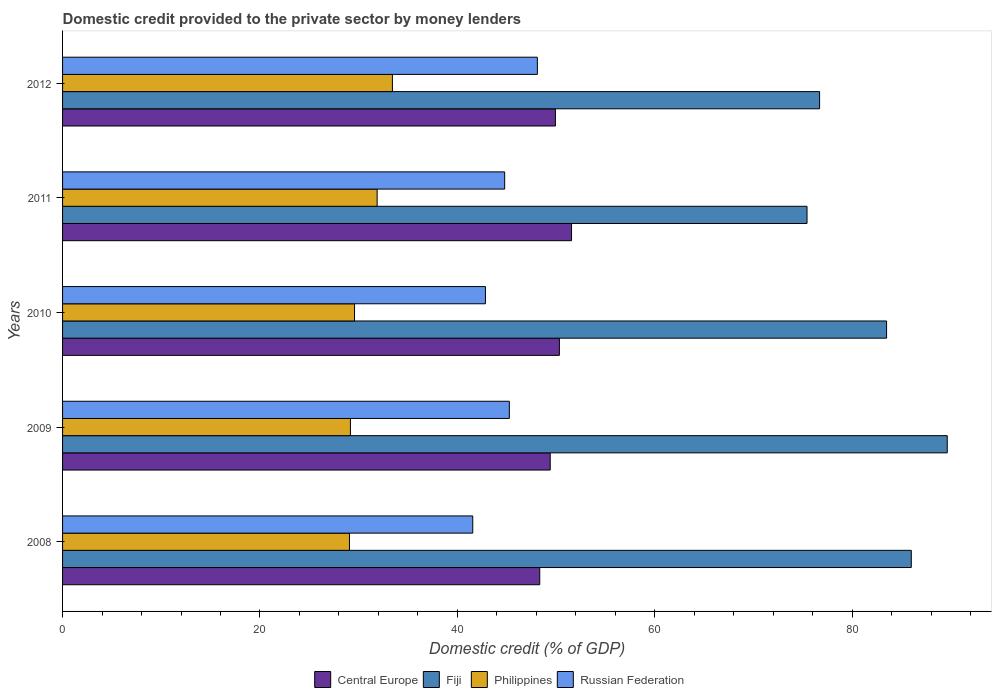How many different coloured bars are there?
Give a very brief answer. 4. How many groups of bars are there?
Your response must be concise. 5. Are the number of bars per tick equal to the number of legend labels?
Offer a terse response. Yes. How many bars are there on the 2nd tick from the top?
Keep it short and to the point. 4. How many bars are there on the 2nd tick from the bottom?
Provide a short and direct response. 4. In how many cases, is the number of bars for a given year not equal to the number of legend labels?
Provide a succinct answer. 0. What is the domestic credit provided to the private sector by money lenders in Philippines in 2012?
Offer a very short reply. 33.41. Across all years, what is the maximum domestic credit provided to the private sector by money lenders in Central Europe?
Ensure brevity in your answer.  51.56. Across all years, what is the minimum domestic credit provided to the private sector by money lenders in Central Europe?
Your answer should be very brief. 48.34. In which year was the domestic credit provided to the private sector by money lenders in Central Europe maximum?
Your answer should be compact. 2011. What is the total domestic credit provided to the private sector by money lenders in Central Europe in the graph?
Ensure brevity in your answer.  249.56. What is the difference between the domestic credit provided to the private sector by money lenders in Philippines in 2009 and that in 2012?
Offer a very short reply. -4.25. What is the difference between the domestic credit provided to the private sector by money lenders in Philippines in 2011 and the domestic credit provided to the private sector by money lenders in Central Europe in 2008?
Keep it short and to the point. -16.47. What is the average domestic credit provided to the private sector by money lenders in Central Europe per year?
Keep it short and to the point. 49.91. In the year 2008, what is the difference between the domestic credit provided to the private sector by money lenders in Philippines and domestic credit provided to the private sector by money lenders in Russian Federation?
Offer a very short reply. -12.49. What is the ratio of the domestic credit provided to the private sector by money lenders in Central Europe in 2009 to that in 2010?
Ensure brevity in your answer.  0.98. Is the domestic credit provided to the private sector by money lenders in Philippines in 2011 less than that in 2012?
Give a very brief answer. Yes. Is the difference between the domestic credit provided to the private sector by money lenders in Philippines in 2011 and 2012 greater than the difference between the domestic credit provided to the private sector by money lenders in Russian Federation in 2011 and 2012?
Provide a short and direct response. Yes. What is the difference between the highest and the second highest domestic credit provided to the private sector by money lenders in Russian Federation?
Make the answer very short. 2.84. What is the difference between the highest and the lowest domestic credit provided to the private sector by money lenders in Russian Federation?
Your answer should be very brief. 6.55. In how many years, is the domestic credit provided to the private sector by money lenders in Russian Federation greater than the average domestic credit provided to the private sector by money lenders in Russian Federation taken over all years?
Ensure brevity in your answer.  3. What does the 3rd bar from the top in 2012 represents?
Offer a very short reply. Fiji. What does the 2nd bar from the bottom in 2009 represents?
Your answer should be very brief. Fiji. Is it the case that in every year, the sum of the domestic credit provided to the private sector by money lenders in Philippines and domestic credit provided to the private sector by money lenders in Central Europe is greater than the domestic credit provided to the private sector by money lenders in Russian Federation?
Your answer should be compact. Yes. Are all the bars in the graph horizontal?
Make the answer very short. Yes. How many years are there in the graph?
Your answer should be compact. 5. Does the graph contain any zero values?
Make the answer very short. No. Does the graph contain grids?
Give a very brief answer. No. Where does the legend appear in the graph?
Offer a very short reply. Bottom center. How many legend labels are there?
Give a very brief answer. 4. What is the title of the graph?
Your answer should be very brief. Domestic credit provided to the private sector by money lenders. What is the label or title of the X-axis?
Make the answer very short. Domestic credit (% of GDP). What is the label or title of the Y-axis?
Your response must be concise. Years. What is the Domestic credit (% of GDP) in Central Europe in 2008?
Your answer should be very brief. 48.34. What is the Domestic credit (% of GDP) in Fiji in 2008?
Offer a very short reply. 85.98. What is the Domestic credit (% of GDP) of Philippines in 2008?
Make the answer very short. 29.06. What is the Domestic credit (% of GDP) in Russian Federation in 2008?
Offer a very short reply. 41.55. What is the Domestic credit (% of GDP) of Central Europe in 2009?
Provide a succinct answer. 49.4. What is the Domestic credit (% of GDP) in Fiji in 2009?
Make the answer very short. 89.62. What is the Domestic credit (% of GDP) of Philippines in 2009?
Provide a short and direct response. 29.16. What is the Domestic credit (% of GDP) of Russian Federation in 2009?
Your answer should be compact. 45.26. What is the Domestic credit (% of GDP) in Central Europe in 2010?
Give a very brief answer. 50.33. What is the Domestic credit (% of GDP) of Fiji in 2010?
Keep it short and to the point. 83.48. What is the Domestic credit (% of GDP) in Philippines in 2010?
Your response must be concise. 29.58. What is the Domestic credit (% of GDP) of Russian Federation in 2010?
Your answer should be very brief. 42.84. What is the Domestic credit (% of GDP) of Central Europe in 2011?
Provide a succinct answer. 51.56. What is the Domestic credit (% of GDP) in Fiji in 2011?
Provide a succinct answer. 75.42. What is the Domestic credit (% of GDP) in Philippines in 2011?
Provide a succinct answer. 31.87. What is the Domestic credit (% of GDP) of Russian Federation in 2011?
Provide a succinct answer. 44.79. What is the Domestic credit (% of GDP) of Central Europe in 2012?
Keep it short and to the point. 49.93. What is the Domestic credit (% of GDP) of Fiji in 2012?
Offer a terse response. 76.69. What is the Domestic credit (% of GDP) of Philippines in 2012?
Your answer should be very brief. 33.41. What is the Domestic credit (% of GDP) of Russian Federation in 2012?
Your answer should be very brief. 48.1. Across all years, what is the maximum Domestic credit (% of GDP) of Central Europe?
Your answer should be compact. 51.56. Across all years, what is the maximum Domestic credit (% of GDP) of Fiji?
Make the answer very short. 89.62. Across all years, what is the maximum Domestic credit (% of GDP) of Philippines?
Your answer should be compact. 33.41. Across all years, what is the maximum Domestic credit (% of GDP) in Russian Federation?
Provide a short and direct response. 48.1. Across all years, what is the minimum Domestic credit (% of GDP) of Central Europe?
Your response must be concise. 48.34. Across all years, what is the minimum Domestic credit (% of GDP) in Fiji?
Your answer should be compact. 75.42. Across all years, what is the minimum Domestic credit (% of GDP) of Philippines?
Provide a succinct answer. 29.06. Across all years, what is the minimum Domestic credit (% of GDP) of Russian Federation?
Ensure brevity in your answer.  41.55. What is the total Domestic credit (% of GDP) in Central Europe in the graph?
Provide a succinct answer. 249.56. What is the total Domestic credit (% of GDP) in Fiji in the graph?
Offer a terse response. 411.19. What is the total Domestic credit (% of GDP) in Philippines in the graph?
Your answer should be very brief. 153.09. What is the total Domestic credit (% of GDP) in Russian Federation in the graph?
Your response must be concise. 222.54. What is the difference between the Domestic credit (% of GDP) of Central Europe in 2008 and that in 2009?
Offer a terse response. -1.06. What is the difference between the Domestic credit (% of GDP) of Fiji in 2008 and that in 2009?
Offer a very short reply. -3.65. What is the difference between the Domestic credit (% of GDP) in Philippines in 2008 and that in 2009?
Provide a short and direct response. -0.1. What is the difference between the Domestic credit (% of GDP) in Russian Federation in 2008 and that in 2009?
Your answer should be compact. -3.71. What is the difference between the Domestic credit (% of GDP) in Central Europe in 2008 and that in 2010?
Your answer should be very brief. -1.99. What is the difference between the Domestic credit (% of GDP) in Fiji in 2008 and that in 2010?
Provide a short and direct response. 2.5. What is the difference between the Domestic credit (% of GDP) of Philippines in 2008 and that in 2010?
Offer a very short reply. -0.51. What is the difference between the Domestic credit (% of GDP) of Russian Federation in 2008 and that in 2010?
Offer a terse response. -1.29. What is the difference between the Domestic credit (% of GDP) of Central Europe in 2008 and that in 2011?
Your response must be concise. -3.22. What is the difference between the Domestic credit (% of GDP) of Fiji in 2008 and that in 2011?
Provide a succinct answer. 10.56. What is the difference between the Domestic credit (% of GDP) of Philippines in 2008 and that in 2011?
Give a very brief answer. -2.8. What is the difference between the Domestic credit (% of GDP) of Russian Federation in 2008 and that in 2011?
Ensure brevity in your answer.  -3.23. What is the difference between the Domestic credit (% of GDP) of Central Europe in 2008 and that in 2012?
Provide a short and direct response. -1.59. What is the difference between the Domestic credit (% of GDP) in Fiji in 2008 and that in 2012?
Provide a succinct answer. 9.29. What is the difference between the Domestic credit (% of GDP) of Philippines in 2008 and that in 2012?
Your response must be concise. -4.35. What is the difference between the Domestic credit (% of GDP) in Russian Federation in 2008 and that in 2012?
Give a very brief answer. -6.55. What is the difference between the Domestic credit (% of GDP) in Central Europe in 2009 and that in 2010?
Provide a succinct answer. -0.93. What is the difference between the Domestic credit (% of GDP) of Fiji in 2009 and that in 2010?
Your answer should be compact. 6.15. What is the difference between the Domestic credit (% of GDP) of Philippines in 2009 and that in 2010?
Ensure brevity in your answer.  -0.42. What is the difference between the Domestic credit (% of GDP) in Russian Federation in 2009 and that in 2010?
Ensure brevity in your answer.  2.42. What is the difference between the Domestic credit (% of GDP) in Central Europe in 2009 and that in 2011?
Provide a succinct answer. -2.16. What is the difference between the Domestic credit (% of GDP) in Fiji in 2009 and that in 2011?
Your answer should be very brief. 14.21. What is the difference between the Domestic credit (% of GDP) in Philippines in 2009 and that in 2011?
Provide a succinct answer. -2.71. What is the difference between the Domestic credit (% of GDP) in Russian Federation in 2009 and that in 2011?
Your answer should be compact. 0.47. What is the difference between the Domestic credit (% of GDP) of Central Europe in 2009 and that in 2012?
Your answer should be very brief. -0.53. What is the difference between the Domestic credit (% of GDP) in Fiji in 2009 and that in 2012?
Offer a very short reply. 12.93. What is the difference between the Domestic credit (% of GDP) in Philippines in 2009 and that in 2012?
Your answer should be very brief. -4.25. What is the difference between the Domestic credit (% of GDP) of Russian Federation in 2009 and that in 2012?
Offer a terse response. -2.84. What is the difference between the Domestic credit (% of GDP) of Central Europe in 2010 and that in 2011?
Your answer should be compact. -1.23. What is the difference between the Domestic credit (% of GDP) of Fiji in 2010 and that in 2011?
Your answer should be compact. 8.06. What is the difference between the Domestic credit (% of GDP) of Philippines in 2010 and that in 2011?
Provide a succinct answer. -2.29. What is the difference between the Domestic credit (% of GDP) in Russian Federation in 2010 and that in 2011?
Give a very brief answer. -1.95. What is the difference between the Domestic credit (% of GDP) of Central Europe in 2010 and that in 2012?
Your response must be concise. 0.4. What is the difference between the Domestic credit (% of GDP) of Fiji in 2010 and that in 2012?
Your response must be concise. 6.78. What is the difference between the Domestic credit (% of GDP) in Philippines in 2010 and that in 2012?
Offer a very short reply. -3.84. What is the difference between the Domestic credit (% of GDP) in Russian Federation in 2010 and that in 2012?
Your answer should be compact. -5.26. What is the difference between the Domestic credit (% of GDP) in Central Europe in 2011 and that in 2012?
Give a very brief answer. 1.63. What is the difference between the Domestic credit (% of GDP) of Fiji in 2011 and that in 2012?
Ensure brevity in your answer.  -1.27. What is the difference between the Domestic credit (% of GDP) of Philippines in 2011 and that in 2012?
Keep it short and to the point. -1.55. What is the difference between the Domestic credit (% of GDP) in Russian Federation in 2011 and that in 2012?
Provide a succinct answer. -3.31. What is the difference between the Domestic credit (% of GDP) in Central Europe in 2008 and the Domestic credit (% of GDP) in Fiji in 2009?
Ensure brevity in your answer.  -41.28. What is the difference between the Domestic credit (% of GDP) in Central Europe in 2008 and the Domestic credit (% of GDP) in Philippines in 2009?
Keep it short and to the point. 19.18. What is the difference between the Domestic credit (% of GDP) of Central Europe in 2008 and the Domestic credit (% of GDP) of Russian Federation in 2009?
Provide a short and direct response. 3.08. What is the difference between the Domestic credit (% of GDP) in Fiji in 2008 and the Domestic credit (% of GDP) in Philippines in 2009?
Keep it short and to the point. 56.82. What is the difference between the Domestic credit (% of GDP) of Fiji in 2008 and the Domestic credit (% of GDP) of Russian Federation in 2009?
Your answer should be compact. 40.72. What is the difference between the Domestic credit (% of GDP) of Philippines in 2008 and the Domestic credit (% of GDP) of Russian Federation in 2009?
Provide a succinct answer. -16.2. What is the difference between the Domestic credit (% of GDP) in Central Europe in 2008 and the Domestic credit (% of GDP) in Fiji in 2010?
Your answer should be compact. -35.14. What is the difference between the Domestic credit (% of GDP) in Central Europe in 2008 and the Domestic credit (% of GDP) in Philippines in 2010?
Provide a succinct answer. 18.76. What is the difference between the Domestic credit (% of GDP) of Central Europe in 2008 and the Domestic credit (% of GDP) of Russian Federation in 2010?
Provide a short and direct response. 5.5. What is the difference between the Domestic credit (% of GDP) of Fiji in 2008 and the Domestic credit (% of GDP) of Philippines in 2010?
Offer a very short reply. 56.4. What is the difference between the Domestic credit (% of GDP) of Fiji in 2008 and the Domestic credit (% of GDP) of Russian Federation in 2010?
Your response must be concise. 43.14. What is the difference between the Domestic credit (% of GDP) in Philippines in 2008 and the Domestic credit (% of GDP) in Russian Federation in 2010?
Make the answer very short. -13.78. What is the difference between the Domestic credit (% of GDP) in Central Europe in 2008 and the Domestic credit (% of GDP) in Fiji in 2011?
Keep it short and to the point. -27.08. What is the difference between the Domestic credit (% of GDP) in Central Europe in 2008 and the Domestic credit (% of GDP) in Philippines in 2011?
Your answer should be very brief. 16.47. What is the difference between the Domestic credit (% of GDP) in Central Europe in 2008 and the Domestic credit (% of GDP) in Russian Federation in 2011?
Your response must be concise. 3.55. What is the difference between the Domestic credit (% of GDP) of Fiji in 2008 and the Domestic credit (% of GDP) of Philippines in 2011?
Your answer should be compact. 54.11. What is the difference between the Domestic credit (% of GDP) in Fiji in 2008 and the Domestic credit (% of GDP) in Russian Federation in 2011?
Ensure brevity in your answer.  41.19. What is the difference between the Domestic credit (% of GDP) of Philippines in 2008 and the Domestic credit (% of GDP) of Russian Federation in 2011?
Offer a very short reply. -15.72. What is the difference between the Domestic credit (% of GDP) of Central Europe in 2008 and the Domestic credit (% of GDP) of Fiji in 2012?
Your answer should be very brief. -28.35. What is the difference between the Domestic credit (% of GDP) in Central Europe in 2008 and the Domestic credit (% of GDP) in Philippines in 2012?
Offer a terse response. 14.93. What is the difference between the Domestic credit (% of GDP) in Central Europe in 2008 and the Domestic credit (% of GDP) in Russian Federation in 2012?
Give a very brief answer. 0.24. What is the difference between the Domestic credit (% of GDP) of Fiji in 2008 and the Domestic credit (% of GDP) of Philippines in 2012?
Your answer should be very brief. 52.57. What is the difference between the Domestic credit (% of GDP) in Fiji in 2008 and the Domestic credit (% of GDP) in Russian Federation in 2012?
Offer a very short reply. 37.88. What is the difference between the Domestic credit (% of GDP) of Philippines in 2008 and the Domestic credit (% of GDP) of Russian Federation in 2012?
Offer a very short reply. -19.04. What is the difference between the Domestic credit (% of GDP) in Central Europe in 2009 and the Domestic credit (% of GDP) in Fiji in 2010?
Offer a very short reply. -34.08. What is the difference between the Domestic credit (% of GDP) in Central Europe in 2009 and the Domestic credit (% of GDP) in Philippines in 2010?
Provide a short and direct response. 19.82. What is the difference between the Domestic credit (% of GDP) in Central Europe in 2009 and the Domestic credit (% of GDP) in Russian Federation in 2010?
Offer a very short reply. 6.56. What is the difference between the Domestic credit (% of GDP) in Fiji in 2009 and the Domestic credit (% of GDP) in Philippines in 2010?
Make the answer very short. 60.05. What is the difference between the Domestic credit (% of GDP) in Fiji in 2009 and the Domestic credit (% of GDP) in Russian Federation in 2010?
Ensure brevity in your answer.  46.78. What is the difference between the Domestic credit (% of GDP) in Philippines in 2009 and the Domestic credit (% of GDP) in Russian Federation in 2010?
Provide a short and direct response. -13.68. What is the difference between the Domestic credit (% of GDP) in Central Europe in 2009 and the Domestic credit (% of GDP) in Fiji in 2011?
Provide a short and direct response. -26.02. What is the difference between the Domestic credit (% of GDP) of Central Europe in 2009 and the Domestic credit (% of GDP) of Philippines in 2011?
Keep it short and to the point. 17.53. What is the difference between the Domestic credit (% of GDP) in Central Europe in 2009 and the Domestic credit (% of GDP) in Russian Federation in 2011?
Provide a succinct answer. 4.61. What is the difference between the Domestic credit (% of GDP) in Fiji in 2009 and the Domestic credit (% of GDP) in Philippines in 2011?
Your answer should be compact. 57.76. What is the difference between the Domestic credit (% of GDP) in Fiji in 2009 and the Domestic credit (% of GDP) in Russian Federation in 2011?
Offer a very short reply. 44.84. What is the difference between the Domestic credit (% of GDP) of Philippines in 2009 and the Domestic credit (% of GDP) of Russian Federation in 2011?
Ensure brevity in your answer.  -15.63. What is the difference between the Domestic credit (% of GDP) of Central Europe in 2009 and the Domestic credit (% of GDP) of Fiji in 2012?
Your answer should be compact. -27.29. What is the difference between the Domestic credit (% of GDP) in Central Europe in 2009 and the Domestic credit (% of GDP) in Philippines in 2012?
Provide a short and direct response. 15.99. What is the difference between the Domestic credit (% of GDP) in Central Europe in 2009 and the Domestic credit (% of GDP) in Russian Federation in 2012?
Offer a terse response. 1.3. What is the difference between the Domestic credit (% of GDP) of Fiji in 2009 and the Domestic credit (% of GDP) of Philippines in 2012?
Provide a succinct answer. 56.21. What is the difference between the Domestic credit (% of GDP) of Fiji in 2009 and the Domestic credit (% of GDP) of Russian Federation in 2012?
Your response must be concise. 41.52. What is the difference between the Domestic credit (% of GDP) in Philippines in 2009 and the Domestic credit (% of GDP) in Russian Federation in 2012?
Offer a terse response. -18.94. What is the difference between the Domestic credit (% of GDP) in Central Europe in 2010 and the Domestic credit (% of GDP) in Fiji in 2011?
Provide a succinct answer. -25.09. What is the difference between the Domestic credit (% of GDP) in Central Europe in 2010 and the Domestic credit (% of GDP) in Philippines in 2011?
Your response must be concise. 18.46. What is the difference between the Domestic credit (% of GDP) in Central Europe in 2010 and the Domestic credit (% of GDP) in Russian Federation in 2011?
Give a very brief answer. 5.54. What is the difference between the Domestic credit (% of GDP) of Fiji in 2010 and the Domestic credit (% of GDP) of Philippines in 2011?
Offer a very short reply. 51.61. What is the difference between the Domestic credit (% of GDP) of Fiji in 2010 and the Domestic credit (% of GDP) of Russian Federation in 2011?
Provide a succinct answer. 38.69. What is the difference between the Domestic credit (% of GDP) of Philippines in 2010 and the Domestic credit (% of GDP) of Russian Federation in 2011?
Your answer should be compact. -15.21. What is the difference between the Domestic credit (% of GDP) in Central Europe in 2010 and the Domestic credit (% of GDP) in Fiji in 2012?
Your response must be concise. -26.36. What is the difference between the Domestic credit (% of GDP) of Central Europe in 2010 and the Domestic credit (% of GDP) of Philippines in 2012?
Offer a very short reply. 16.92. What is the difference between the Domestic credit (% of GDP) in Central Europe in 2010 and the Domestic credit (% of GDP) in Russian Federation in 2012?
Your response must be concise. 2.23. What is the difference between the Domestic credit (% of GDP) in Fiji in 2010 and the Domestic credit (% of GDP) in Philippines in 2012?
Your answer should be compact. 50.06. What is the difference between the Domestic credit (% of GDP) of Fiji in 2010 and the Domestic credit (% of GDP) of Russian Federation in 2012?
Ensure brevity in your answer.  35.38. What is the difference between the Domestic credit (% of GDP) of Philippines in 2010 and the Domestic credit (% of GDP) of Russian Federation in 2012?
Make the answer very short. -18.52. What is the difference between the Domestic credit (% of GDP) in Central Europe in 2011 and the Domestic credit (% of GDP) in Fiji in 2012?
Make the answer very short. -25.13. What is the difference between the Domestic credit (% of GDP) in Central Europe in 2011 and the Domestic credit (% of GDP) in Philippines in 2012?
Make the answer very short. 18.15. What is the difference between the Domestic credit (% of GDP) of Central Europe in 2011 and the Domestic credit (% of GDP) of Russian Federation in 2012?
Offer a very short reply. 3.46. What is the difference between the Domestic credit (% of GDP) in Fiji in 2011 and the Domestic credit (% of GDP) in Philippines in 2012?
Offer a terse response. 42. What is the difference between the Domestic credit (% of GDP) of Fiji in 2011 and the Domestic credit (% of GDP) of Russian Federation in 2012?
Give a very brief answer. 27.32. What is the difference between the Domestic credit (% of GDP) of Philippines in 2011 and the Domestic credit (% of GDP) of Russian Federation in 2012?
Make the answer very short. -16.23. What is the average Domestic credit (% of GDP) in Central Europe per year?
Offer a very short reply. 49.91. What is the average Domestic credit (% of GDP) in Fiji per year?
Your response must be concise. 82.24. What is the average Domestic credit (% of GDP) in Philippines per year?
Ensure brevity in your answer.  30.62. What is the average Domestic credit (% of GDP) of Russian Federation per year?
Offer a very short reply. 44.51. In the year 2008, what is the difference between the Domestic credit (% of GDP) in Central Europe and Domestic credit (% of GDP) in Fiji?
Your answer should be compact. -37.64. In the year 2008, what is the difference between the Domestic credit (% of GDP) of Central Europe and Domestic credit (% of GDP) of Philippines?
Offer a terse response. 19.28. In the year 2008, what is the difference between the Domestic credit (% of GDP) in Central Europe and Domestic credit (% of GDP) in Russian Federation?
Offer a terse response. 6.79. In the year 2008, what is the difference between the Domestic credit (% of GDP) of Fiji and Domestic credit (% of GDP) of Philippines?
Ensure brevity in your answer.  56.91. In the year 2008, what is the difference between the Domestic credit (% of GDP) of Fiji and Domestic credit (% of GDP) of Russian Federation?
Your answer should be very brief. 44.43. In the year 2008, what is the difference between the Domestic credit (% of GDP) in Philippines and Domestic credit (% of GDP) in Russian Federation?
Your answer should be very brief. -12.49. In the year 2009, what is the difference between the Domestic credit (% of GDP) in Central Europe and Domestic credit (% of GDP) in Fiji?
Offer a terse response. -40.22. In the year 2009, what is the difference between the Domestic credit (% of GDP) of Central Europe and Domestic credit (% of GDP) of Philippines?
Provide a succinct answer. 20.24. In the year 2009, what is the difference between the Domestic credit (% of GDP) of Central Europe and Domestic credit (% of GDP) of Russian Federation?
Provide a short and direct response. 4.14. In the year 2009, what is the difference between the Domestic credit (% of GDP) of Fiji and Domestic credit (% of GDP) of Philippines?
Provide a short and direct response. 60.46. In the year 2009, what is the difference between the Domestic credit (% of GDP) of Fiji and Domestic credit (% of GDP) of Russian Federation?
Keep it short and to the point. 44.36. In the year 2009, what is the difference between the Domestic credit (% of GDP) of Philippines and Domestic credit (% of GDP) of Russian Federation?
Give a very brief answer. -16.1. In the year 2010, what is the difference between the Domestic credit (% of GDP) of Central Europe and Domestic credit (% of GDP) of Fiji?
Keep it short and to the point. -33.15. In the year 2010, what is the difference between the Domestic credit (% of GDP) in Central Europe and Domestic credit (% of GDP) in Philippines?
Ensure brevity in your answer.  20.75. In the year 2010, what is the difference between the Domestic credit (% of GDP) in Central Europe and Domestic credit (% of GDP) in Russian Federation?
Offer a terse response. 7.49. In the year 2010, what is the difference between the Domestic credit (% of GDP) of Fiji and Domestic credit (% of GDP) of Philippines?
Provide a short and direct response. 53.9. In the year 2010, what is the difference between the Domestic credit (% of GDP) in Fiji and Domestic credit (% of GDP) in Russian Federation?
Ensure brevity in your answer.  40.64. In the year 2010, what is the difference between the Domestic credit (% of GDP) in Philippines and Domestic credit (% of GDP) in Russian Federation?
Your answer should be compact. -13.26. In the year 2011, what is the difference between the Domestic credit (% of GDP) in Central Europe and Domestic credit (% of GDP) in Fiji?
Make the answer very short. -23.86. In the year 2011, what is the difference between the Domestic credit (% of GDP) in Central Europe and Domestic credit (% of GDP) in Philippines?
Offer a very short reply. 19.69. In the year 2011, what is the difference between the Domestic credit (% of GDP) of Central Europe and Domestic credit (% of GDP) of Russian Federation?
Your answer should be very brief. 6.77. In the year 2011, what is the difference between the Domestic credit (% of GDP) in Fiji and Domestic credit (% of GDP) in Philippines?
Ensure brevity in your answer.  43.55. In the year 2011, what is the difference between the Domestic credit (% of GDP) of Fiji and Domestic credit (% of GDP) of Russian Federation?
Offer a terse response. 30.63. In the year 2011, what is the difference between the Domestic credit (% of GDP) in Philippines and Domestic credit (% of GDP) in Russian Federation?
Make the answer very short. -12.92. In the year 2012, what is the difference between the Domestic credit (% of GDP) in Central Europe and Domestic credit (% of GDP) in Fiji?
Ensure brevity in your answer.  -26.76. In the year 2012, what is the difference between the Domestic credit (% of GDP) of Central Europe and Domestic credit (% of GDP) of Philippines?
Ensure brevity in your answer.  16.51. In the year 2012, what is the difference between the Domestic credit (% of GDP) of Central Europe and Domestic credit (% of GDP) of Russian Federation?
Provide a short and direct response. 1.83. In the year 2012, what is the difference between the Domestic credit (% of GDP) in Fiji and Domestic credit (% of GDP) in Philippines?
Make the answer very short. 43.28. In the year 2012, what is the difference between the Domestic credit (% of GDP) of Fiji and Domestic credit (% of GDP) of Russian Federation?
Make the answer very short. 28.59. In the year 2012, what is the difference between the Domestic credit (% of GDP) of Philippines and Domestic credit (% of GDP) of Russian Federation?
Your answer should be compact. -14.69. What is the ratio of the Domestic credit (% of GDP) in Central Europe in 2008 to that in 2009?
Make the answer very short. 0.98. What is the ratio of the Domestic credit (% of GDP) in Fiji in 2008 to that in 2009?
Your answer should be compact. 0.96. What is the ratio of the Domestic credit (% of GDP) of Philippines in 2008 to that in 2009?
Make the answer very short. 1. What is the ratio of the Domestic credit (% of GDP) in Russian Federation in 2008 to that in 2009?
Provide a succinct answer. 0.92. What is the ratio of the Domestic credit (% of GDP) in Central Europe in 2008 to that in 2010?
Make the answer very short. 0.96. What is the ratio of the Domestic credit (% of GDP) of Fiji in 2008 to that in 2010?
Keep it short and to the point. 1.03. What is the ratio of the Domestic credit (% of GDP) in Philippines in 2008 to that in 2010?
Your answer should be very brief. 0.98. What is the ratio of the Domestic credit (% of GDP) in Russian Federation in 2008 to that in 2010?
Offer a very short reply. 0.97. What is the ratio of the Domestic credit (% of GDP) in Central Europe in 2008 to that in 2011?
Offer a very short reply. 0.94. What is the ratio of the Domestic credit (% of GDP) in Fiji in 2008 to that in 2011?
Keep it short and to the point. 1.14. What is the ratio of the Domestic credit (% of GDP) of Philippines in 2008 to that in 2011?
Keep it short and to the point. 0.91. What is the ratio of the Domestic credit (% of GDP) of Russian Federation in 2008 to that in 2011?
Ensure brevity in your answer.  0.93. What is the ratio of the Domestic credit (% of GDP) in Central Europe in 2008 to that in 2012?
Your response must be concise. 0.97. What is the ratio of the Domestic credit (% of GDP) in Fiji in 2008 to that in 2012?
Keep it short and to the point. 1.12. What is the ratio of the Domestic credit (% of GDP) in Philippines in 2008 to that in 2012?
Make the answer very short. 0.87. What is the ratio of the Domestic credit (% of GDP) of Russian Federation in 2008 to that in 2012?
Offer a very short reply. 0.86. What is the ratio of the Domestic credit (% of GDP) in Central Europe in 2009 to that in 2010?
Provide a short and direct response. 0.98. What is the ratio of the Domestic credit (% of GDP) of Fiji in 2009 to that in 2010?
Offer a terse response. 1.07. What is the ratio of the Domestic credit (% of GDP) of Philippines in 2009 to that in 2010?
Make the answer very short. 0.99. What is the ratio of the Domestic credit (% of GDP) of Russian Federation in 2009 to that in 2010?
Ensure brevity in your answer.  1.06. What is the ratio of the Domestic credit (% of GDP) in Central Europe in 2009 to that in 2011?
Offer a very short reply. 0.96. What is the ratio of the Domestic credit (% of GDP) of Fiji in 2009 to that in 2011?
Give a very brief answer. 1.19. What is the ratio of the Domestic credit (% of GDP) of Philippines in 2009 to that in 2011?
Your answer should be very brief. 0.92. What is the ratio of the Domestic credit (% of GDP) in Russian Federation in 2009 to that in 2011?
Your answer should be compact. 1.01. What is the ratio of the Domestic credit (% of GDP) of Central Europe in 2009 to that in 2012?
Give a very brief answer. 0.99. What is the ratio of the Domestic credit (% of GDP) of Fiji in 2009 to that in 2012?
Provide a succinct answer. 1.17. What is the ratio of the Domestic credit (% of GDP) of Philippines in 2009 to that in 2012?
Provide a short and direct response. 0.87. What is the ratio of the Domestic credit (% of GDP) of Russian Federation in 2009 to that in 2012?
Make the answer very short. 0.94. What is the ratio of the Domestic credit (% of GDP) of Central Europe in 2010 to that in 2011?
Give a very brief answer. 0.98. What is the ratio of the Domestic credit (% of GDP) in Fiji in 2010 to that in 2011?
Give a very brief answer. 1.11. What is the ratio of the Domestic credit (% of GDP) in Philippines in 2010 to that in 2011?
Offer a terse response. 0.93. What is the ratio of the Domestic credit (% of GDP) of Russian Federation in 2010 to that in 2011?
Your answer should be compact. 0.96. What is the ratio of the Domestic credit (% of GDP) in Fiji in 2010 to that in 2012?
Keep it short and to the point. 1.09. What is the ratio of the Domestic credit (% of GDP) of Philippines in 2010 to that in 2012?
Your answer should be very brief. 0.89. What is the ratio of the Domestic credit (% of GDP) of Russian Federation in 2010 to that in 2012?
Provide a succinct answer. 0.89. What is the ratio of the Domestic credit (% of GDP) in Central Europe in 2011 to that in 2012?
Provide a succinct answer. 1.03. What is the ratio of the Domestic credit (% of GDP) in Fiji in 2011 to that in 2012?
Offer a very short reply. 0.98. What is the ratio of the Domestic credit (% of GDP) in Philippines in 2011 to that in 2012?
Make the answer very short. 0.95. What is the ratio of the Domestic credit (% of GDP) of Russian Federation in 2011 to that in 2012?
Give a very brief answer. 0.93. What is the difference between the highest and the second highest Domestic credit (% of GDP) of Central Europe?
Offer a very short reply. 1.23. What is the difference between the highest and the second highest Domestic credit (% of GDP) of Fiji?
Give a very brief answer. 3.65. What is the difference between the highest and the second highest Domestic credit (% of GDP) of Philippines?
Ensure brevity in your answer.  1.55. What is the difference between the highest and the second highest Domestic credit (% of GDP) in Russian Federation?
Keep it short and to the point. 2.84. What is the difference between the highest and the lowest Domestic credit (% of GDP) in Central Europe?
Make the answer very short. 3.22. What is the difference between the highest and the lowest Domestic credit (% of GDP) in Fiji?
Offer a terse response. 14.21. What is the difference between the highest and the lowest Domestic credit (% of GDP) in Philippines?
Provide a short and direct response. 4.35. What is the difference between the highest and the lowest Domestic credit (% of GDP) in Russian Federation?
Give a very brief answer. 6.55. 